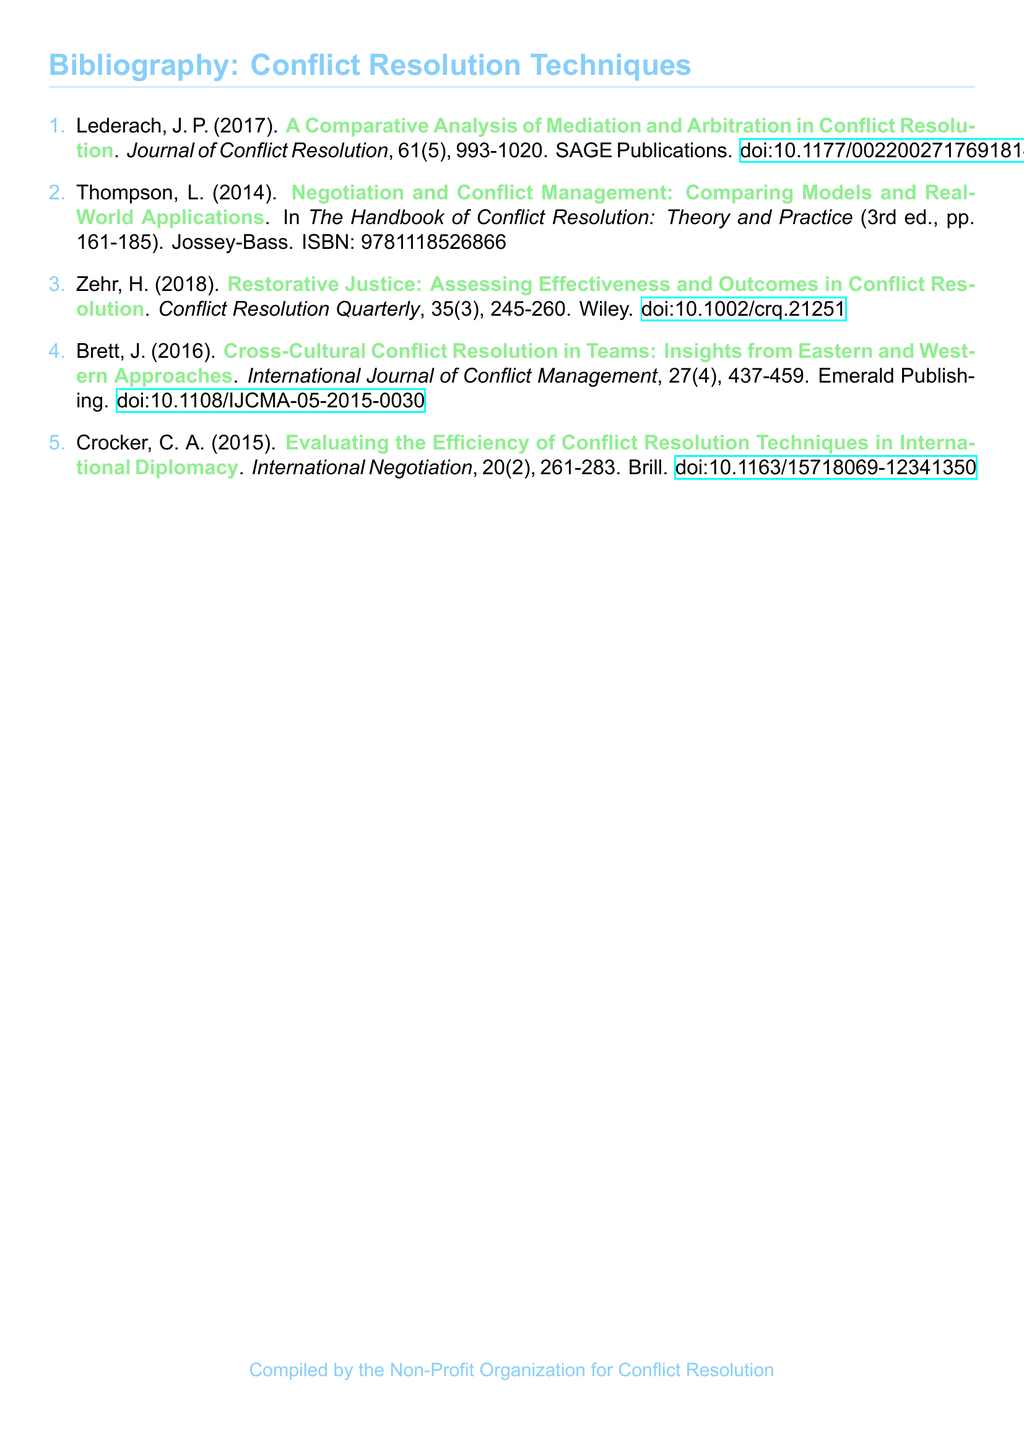What is the title of the first entry? The title of the first entry is found in the first citation of the bibliography, which is "A Comparative Analysis of Mediation and Arbitration in Conflict Resolution."
Answer: A Comparative Analysis of Mediation and Arbitration in Conflict Resolution Who is the author of the second entry? The author is identified at the beginning of the second citation in the bibliography, which is L. Thompson.
Answer: L. Thompson In which journal was the third entry published? The name of the journal is specified in the third citation as "Conflict Resolution Quarterly."
Answer: Conflict Resolution Quarterly What is the publication year of the fourth entry? The publication year is stated in the fourth citation and is 2016.
Answer: 2016 How many pages does the second entry cover? The range of pages for the second entry is indicated in the citation, which is from page 161 to page 185.
Answer: 161-185 Which technique is assessed in the third entry? The technique being assessed is specified in the title of the third entry as "Restorative Justice."
Answer: Restorative Justice What is the volume number of the journal for the first entry? The volume number can be found in the citation of the first entry, which is 61.
Answer: 61 Which publisher is associated with the last entry? The publisher's name can be found at the end of the last entry, which is Brill.
Answer: Brill 